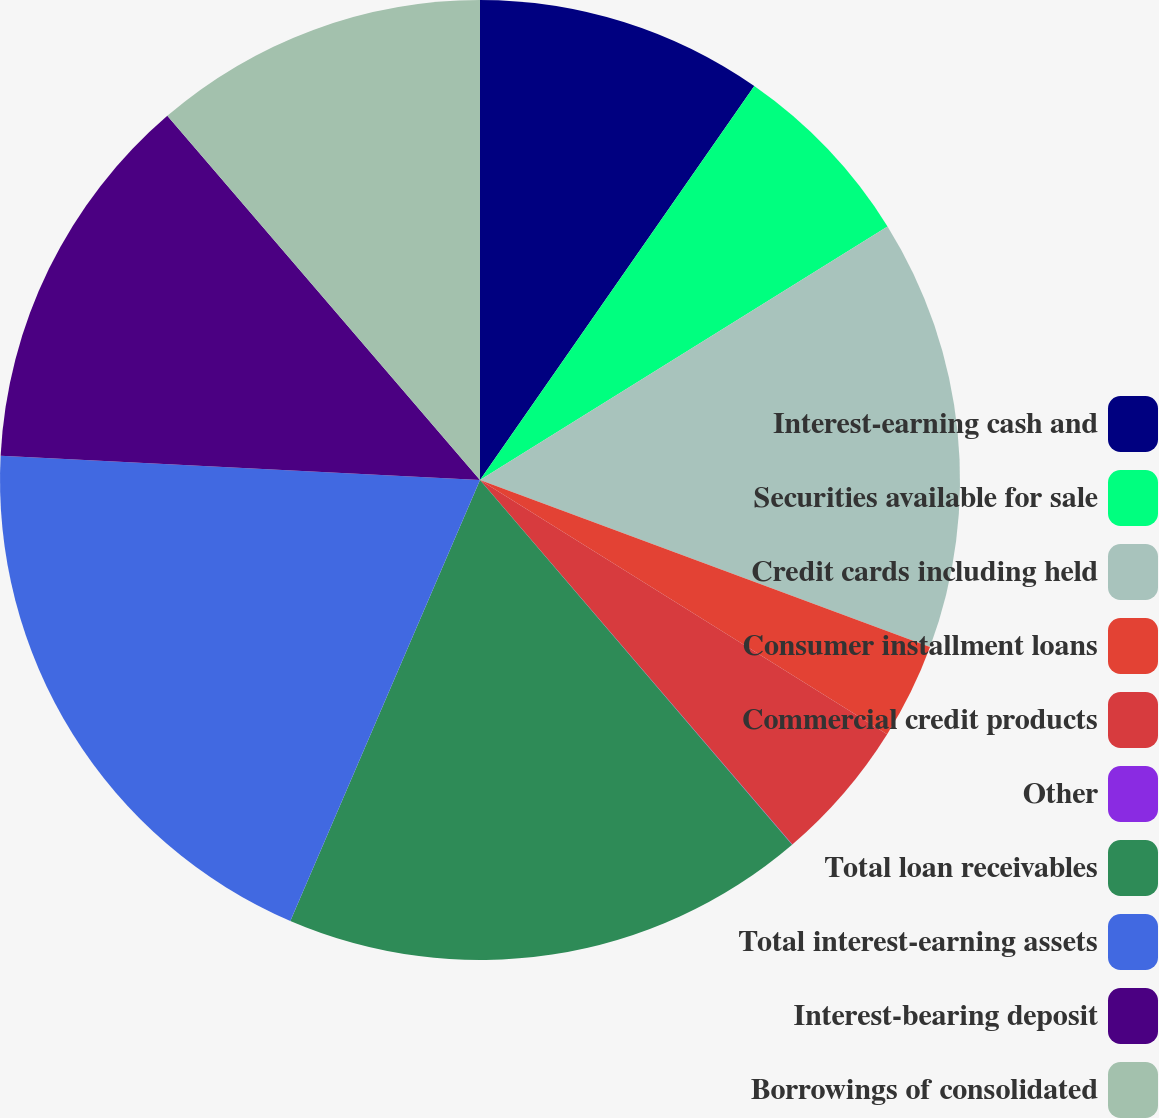Convert chart to OTSL. <chart><loc_0><loc_0><loc_500><loc_500><pie_chart><fcel>Interest-earning cash and<fcel>Securities available for sale<fcel>Credit cards including held<fcel>Consumer installment loans<fcel>Commercial credit products<fcel>Other<fcel>Total loan receivables<fcel>Total interest-earning assets<fcel>Interest-bearing deposit<fcel>Borrowings of consolidated<nl><fcel>9.68%<fcel>6.46%<fcel>14.51%<fcel>3.23%<fcel>4.84%<fcel>0.01%<fcel>17.73%<fcel>19.34%<fcel>12.9%<fcel>11.29%<nl></chart> 